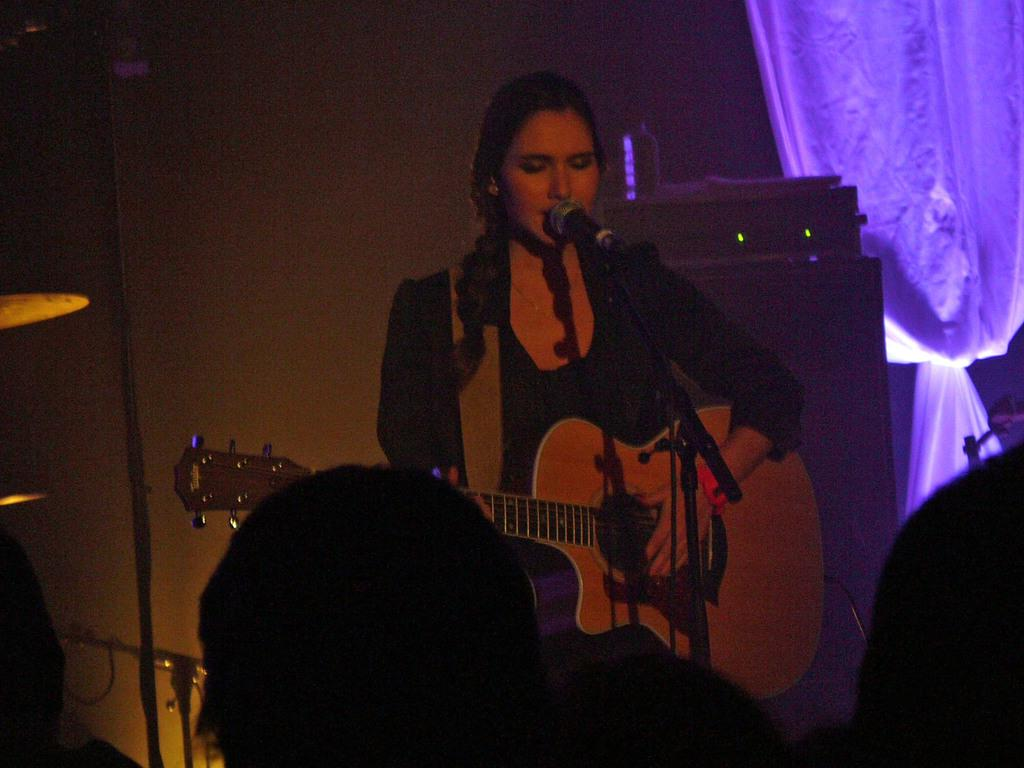What is the woman in the image doing? The woman is standing, playing a guitar, singing, and using a microphone. What can be seen in the background of the image? There are curtains in the image, which are attached to a wall. Who else is present in the image? There are people in the image, and they are watching the woman. What type of cloth is being used to cover the back of the woman in the image? There is no cloth covering the back of the woman in the image. What is the end result of the woman's performance in the image? The image does not show the end result of the woman's performance; it only captures a moment in time. 